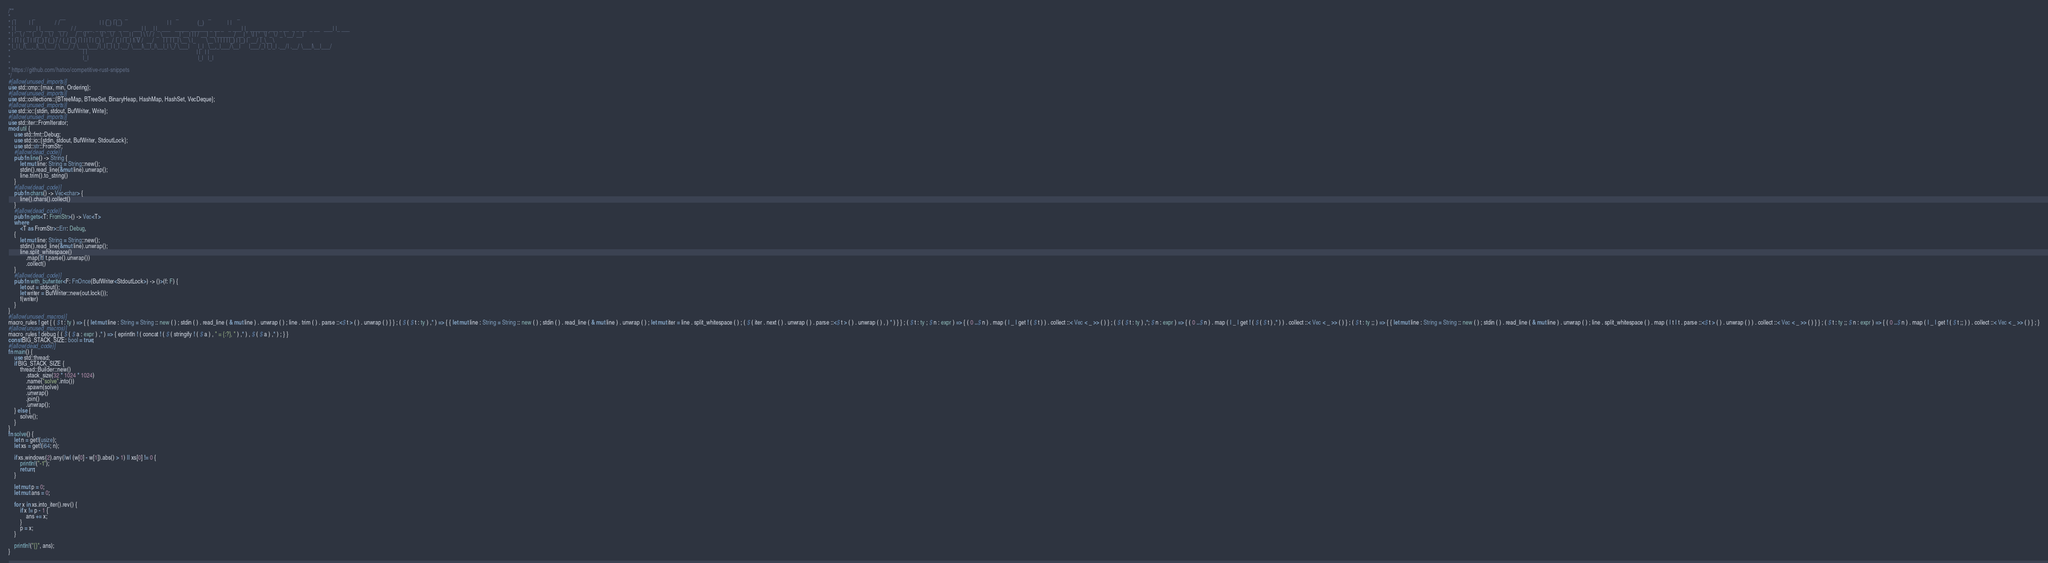<code> <loc_0><loc_0><loc_500><loc_500><_Rust_>/**
*  _           _                 __                            _   _ _   _                                 _                    _                  _
* | |         | |               / /                           | | (_) | (_)                               | |                  (_)                | |
* | |__   __ _| |_ ___   ___   / /__ ___  _ __ ___  _ __   ___| |_ _| |_ ___   _____ ______ _ __ _   _ ___| |_ ______ ___ _ __  _ _ __  _ __   ___| |_ ___
* | '_ \ / _` | __/ _ \ / _ \ / / __/ _ \| '_ ` _ \| '_ \ / _ \ __| | __| \ \ / / _ \______| '__| | | / __| __|______/ __| '_ \| | '_ \| '_ \ / _ \ __/ __|
* | | | | (_| | || (_) | (_) / / (_| (_) | | | | | | |_) |  __/ |_| | |_| |\ V /  __/      | |  | |_| \__ \ |_       \__ \ | | | | |_) | |_) |  __/ |_\__ \
* |_| |_|\__,_|\__\___/ \___/_/ \___\___/|_| |_| |_| .__/ \___|\__|_|\__|_| \_/ \___|      |_|   \__,_|___/\__|      |___/_| |_|_| .__/| .__/ \___|\__|___/
*                                                  | |                                                                           | |   | |
*                                                  |_|                                                                           |_|   |_|
*
* https://github.com/hatoo/competitive-rust-snippets
*/
#[allow(unused_imports)]
use std::cmp::{max, min, Ordering};
#[allow(unused_imports)]
use std::collections::{BTreeMap, BTreeSet, BinaryHeap, HashMap, HashSet, VecDeque};
#[allow(unused_imports)]
use std::io::{stdin, stdout, BufWriter, Write};
#[allow(unused_imports)]
use std::iter::FromIterator;
mod util {
    use std::fmt::Debug;
    use std::io::{stdin, stdout, BufWriter, StdoutLock};
    use std::str::FromStr;
    #[allow(dead_code)]
    pub fn line() -> String {
        let mut line: String = String::new();
        stdin().read_line(&mut line).unwrap();
        line.trim().to_string()
    }
    #[allow(dead_code)]
    pub fn chars() -> Vec<char> {
        line().chars().collect()
    }
    #[allow(dead_code)]
    pub fn gets<T: FromStr>() -> Vec<T>
    where
        <T as FromStr>::Err: Debug,
    {
        let mut line: String = String::new();
        stdin().read_line(&mut line).unwrap();
        line.split_whitespace()
            .map(|t| t.parse().unwrap())
            .collect()
    }
    #[allow(dead_code)]
    pub fn with_bufwriter<F: FnOnce(BufWriter<StdoutLock>) -> ()>(f: F) {
        let out = stdout();
        let writer = BufWriter::new(out.lock());
        f(writer)
    }
}
#[allow(unused_macros)]
macro_rules ! get { ( $ t : ty ) => { { let mut line : String = String :: new ( ) ; stdin ( ) . read_line ( & mut line ) . unwrap ( ) ; line . trim ( ) . parse ::<$ t > ( ) . unwrap ( ) } } ; ( $ ( $ t : ty ) ,* ) => { { let mut line : String = String :: new ( ) ; stdin ( ) . read_line ( & mut line ) . unwrap ( ) ; let mut iter = line . split_whitespace ( ) ; ( $ ( iter . next ( ) . unwrap ( ) . parse ::<$ t > ( ) . unwrap ( ) , ) * ) } } ; ( $ t : ty ; $ n : expr ) => { ( 0 ..$ n ) . map ( | _ | get ! ( $ t ) ) . collect ::< Vec < _ >> ( ) } ; ( $ ( $ t : ty ) ,*; $ n : expr ) => { ( 0 ..$ n ) . map ( | _ | get ! ( $ ( $ t ) ,* ) ) . collect ::< Vec < _ >> ( ) } ; ( $ t : ty ;; ) => { { let mut line : String = String :: new ( ) ; stdin ( ) . read_line ( & mut line ) . unwrap ( ) ; line . split_whitespace ( ) . map ( | t | t . parse ::<$ t > ( ) . unwrap ( ) ) . collect ::< Vec < _ >> ( ) } } ; ( $ t : ty ;; $ n : expr ) => { ( 0 ..$ n ) . map ( | _ | get ! ( $ t ;; ) ) . collect ::< Vec < _ >> ( ) } ; }
#[allow(unused_macros)]
macro_rules ! debug { ( $ ( $ a : expr ) ,* ) => { eprintln ! ( concat ! ( $ ( stringify ! ( $ a ) , " = {:?}, " ) ,* ) , $ ( $ a ) ,* ) ; } }
const BIG_STACK_SIZE: bool = true;
#[allow(dead_code)]
fn main() {
    use std::thread;
    if BIG_STACK_SIZE {
        thread::Builder::new()
            .stack_size(32 * 1024 * 1024)
            .name("solve".into())
            .spawn(solve)
            .unwrap()
            .join()
            .unwrap();
    } else {
        solve();
    }
}
fn solve() {
    let n = get!(usize);
    let xs = get!(i64; n);

    if xs.windows(2).any(|w| (w[0] - w[1]).abs() > 1) || xs[0] != 0 {
        println!("-1");
        return;
    }

    let mut p = 0;
    let mut ans = 0;

    for x in xs.into_iter().rev() {
        if x != p - 1 {
            ans += x;
        }
        p = x;
    }

    println!("{}", ans);
}
</code> 